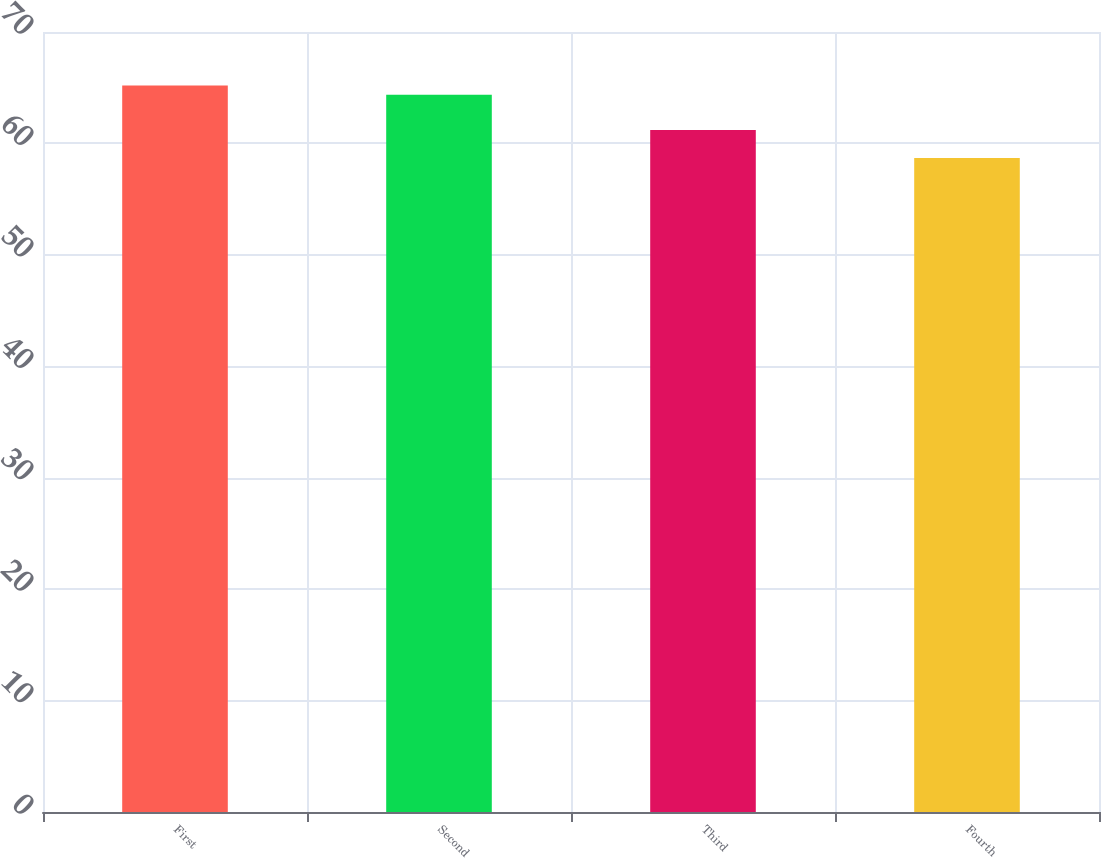Convert chart. <chart><loc_0><loc_0><loc_500><loc_500><bar_chart><fcel>First<fcel>Second<fcel>Third<fcel>Fourth<nl><fcel>65.19<fcel>64.37<fcel>61.21<fcel>58.7<nl></chart> 